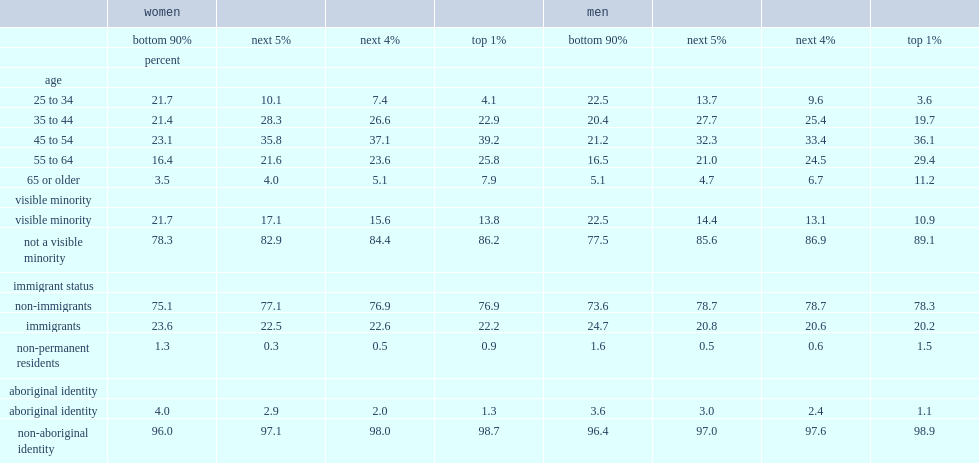What was the percentage of working women in the top 1% between 25 and 54 in 2015? 66.2. What was the percentage of working women in the top 1% between 25 and 44. 27. What was the percentage of working women in the top 1% belonging to a visible minority group. 13.8. 